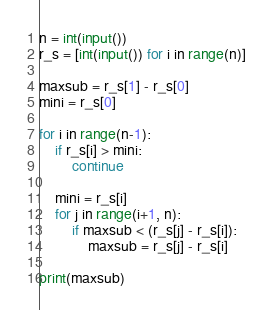Convert code to text. <code><loc_0><loc_0><loc_500><loc_500><_Python_>n = int(input())
r_s = [int(input()) for i in range(n)]

maxsub = r_s[1] - r_s[0]
mini = r_s[0]

for i in range(n-1):
    if r_s[i] > mini:
        continue

    mini = r_s[i]
    for j in range(i+1, n):
        if maxsub < (r_s[j] - r_s[i]):
            maxsub = r_s[j] - r_s[i]

print(maxsub)</code> 